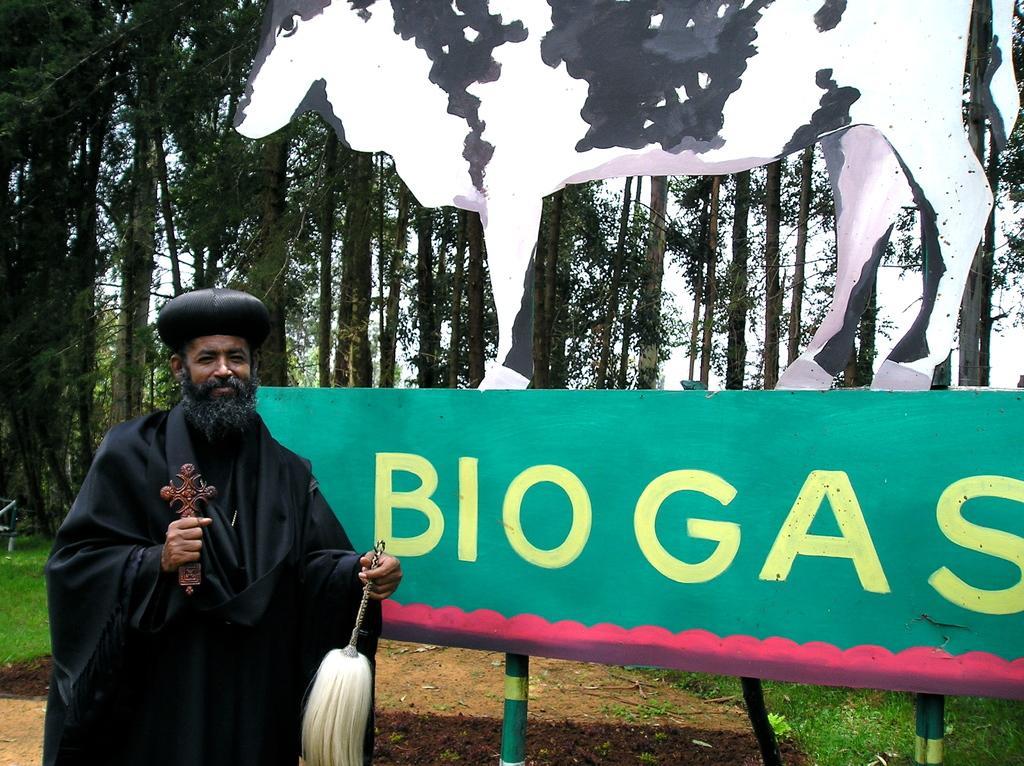Describe this image in one or two sentences. In this image there is a person standing beside the board holding somethings in which bio gas is written and cow sculpture on it, also there are so many trees at the back. 